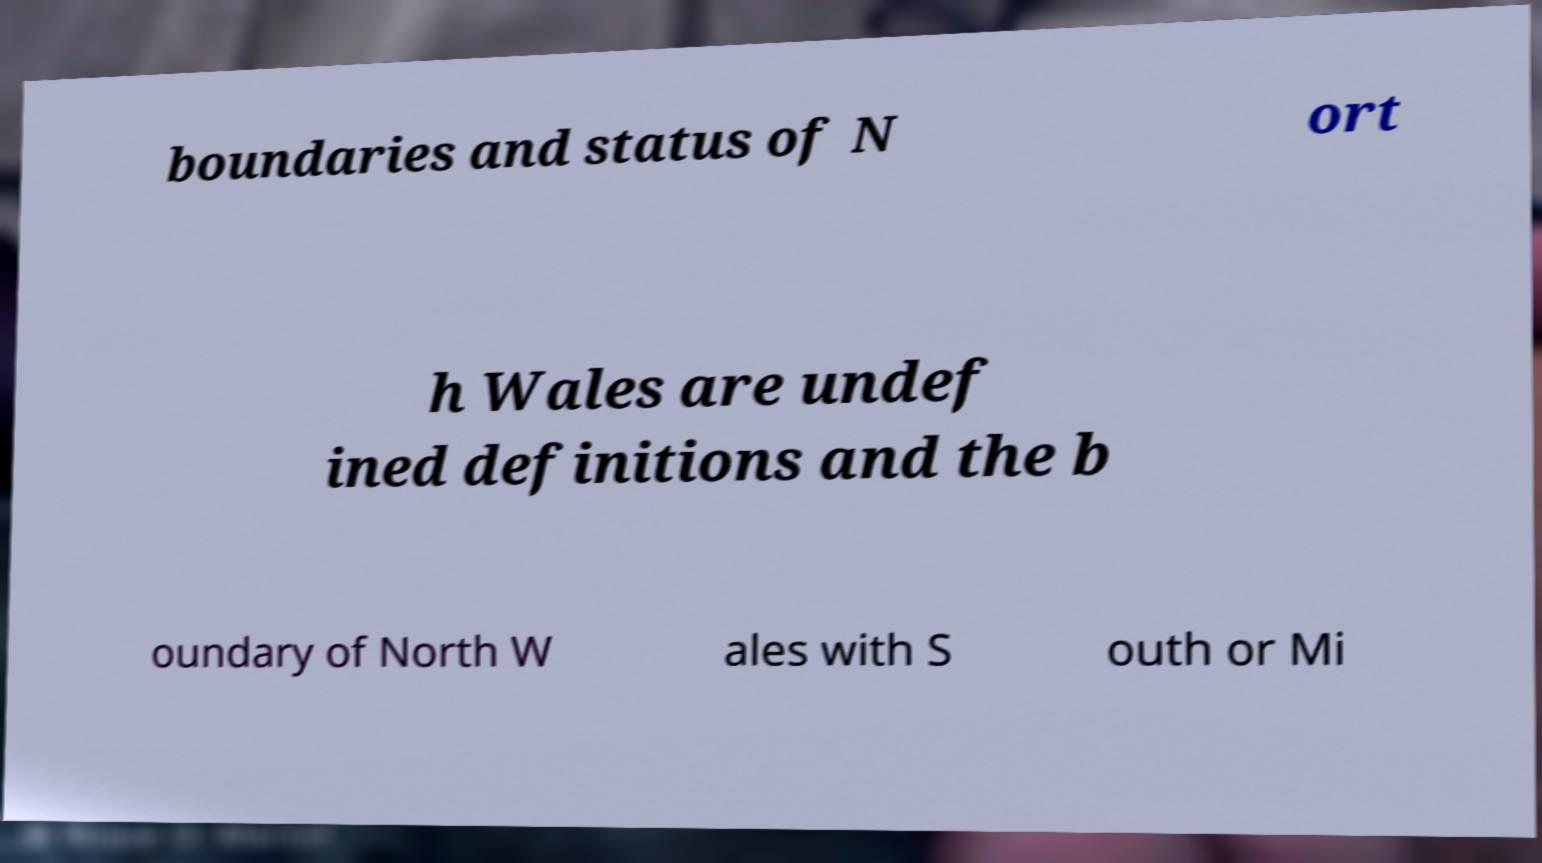Please identify and transcribe the text found in this image. boundaries and status of N ort h Wales are undef ined definitions and the b oundary of North W ales with S outh or Mi 